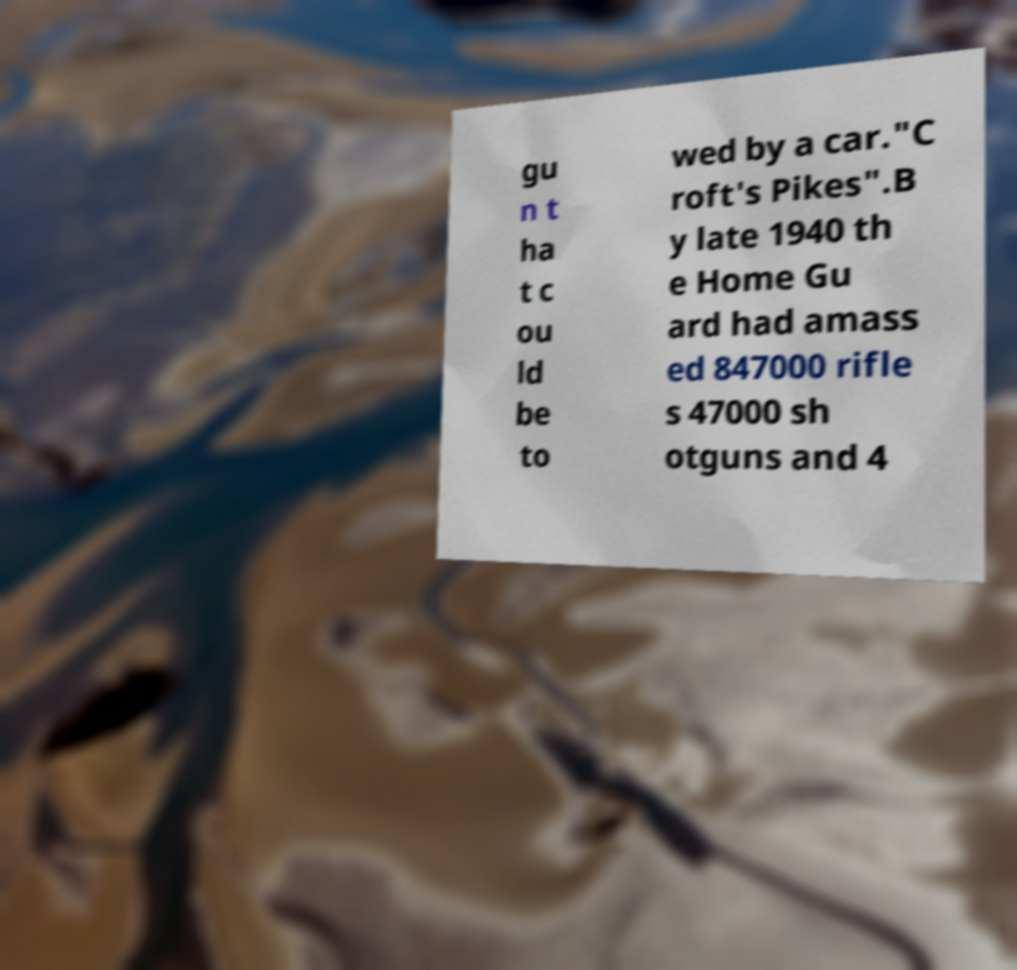Please identify and transcribe the text found in this image. gu n t ha t c ou ld be to wed by a car."C roft's Pikes".B y late 1940 th e Home Gu ard had amass ed 847000 rifle s 47000 sh otguns and 4 